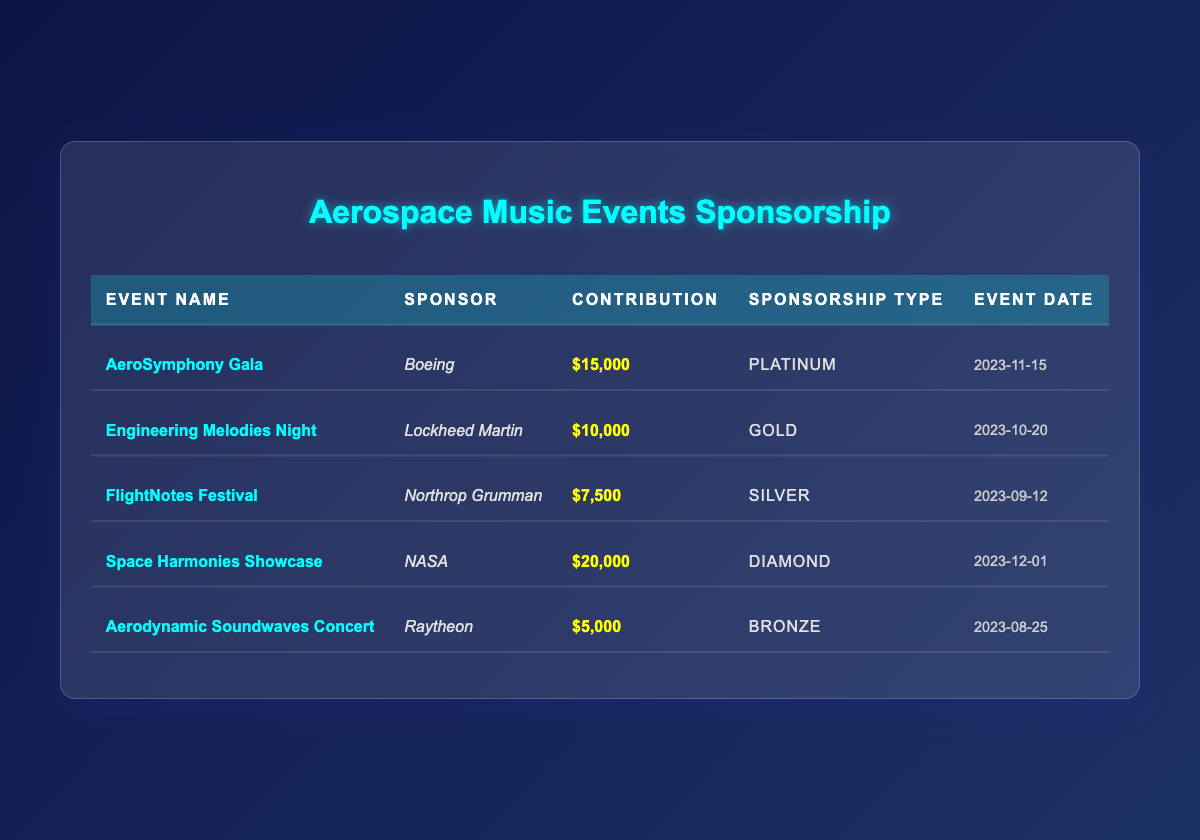What is the highest contribution amount from a sponsor? The contributions listed are: $15,000 (Boeing), $10,000 (Lockheed Martin), $7,500 (Northrop Grumman), $20,000 (NASA), and $5,000 (Raytheon). The highest amount is $20,000 provided by NASA.
Answer: $20,000 Which event is sponsored by Lockheed Martin? The table shows that Lockheed Martin is the sponsor for the event named "Engineering Melodies Night".
Answer: Engineering Melodies Night How many events received a contribution of $10,000 or more? The contributions of $10,000 or more are from Boeing, Lockheed Martin, and NASA, totaling three events: "AeroSymphony Gala", "Engineering Melodies Night", and "Space Harmonies Showcase".
Answer: 3 What is the average contribution amount across all events? The total contributions are $15,000 + $10,000 + $7,500 + $20,000 + $5,000 = $57,500. There are 5 events, so the average is $57,500 divided by 5 which equals $11,500.
Answer: $11,500 Is the "Aerodynamic Soundwaves Concert" a Platinum sponsorship? The table shows that the "Aerodynamic Soundwaves Concert" was sponsored by Raytheon with a Bronze sponsorship type, which is not Platinum.
Answer: No Which sponsorship type received the lowest amount? The contributions for each type are: Bronze ($5,000), Silver ($7,500), Gold ($10,000), Platinum ($15,000), and Diamond ($20,000). The Bronze sponsorship received the lowest amount at $5,000.
Answer: Bronze Which event has the latest date among those listed? The event dates are: November 15, 2023 for "AeroSymphony Gala", October 20, 2023 for "Engineering Melodies Night", September 12, 2023 for "FlightNotes Festival", December 1, 2023 for "Space Harmonies Showcase", and August 25, 2023 for "Aerodynamic Soundwaves Concert". The latest date is December 1, 2023.
Answer: Space Harmonies Showcase What is the total contribution from all sponsors? Adding all contributions together gives: $15,000 + $10,000 + $7,500 + $20,000 + $5,000 = $57,500, which denotes the total contribution from all sponsors.
Answer: $57,500 